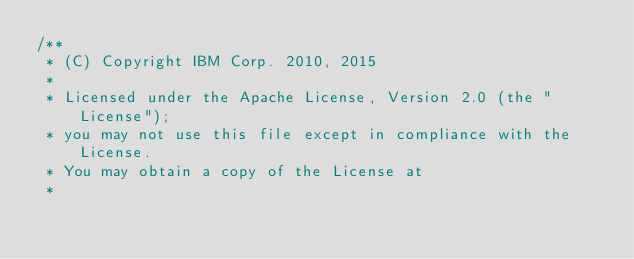Convert code to text. <code><loc_0><loc_0><loc_500><loc_500><_Java_>/**
 * (C) Copyright IBM Corp. 2010, 2015
 *
 * Licensed under the Apache License, Version 2.0 (the "License");
 * you may not use this file except in compliance with the License.
 * You may obtain a copy of the License at
 *</code> 